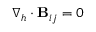Convert formula to latex. <formula><loc_0><loc_0><loc_500><loc_500>\nabla _ { h } \cdot B _ { i j } = 0</formula> 